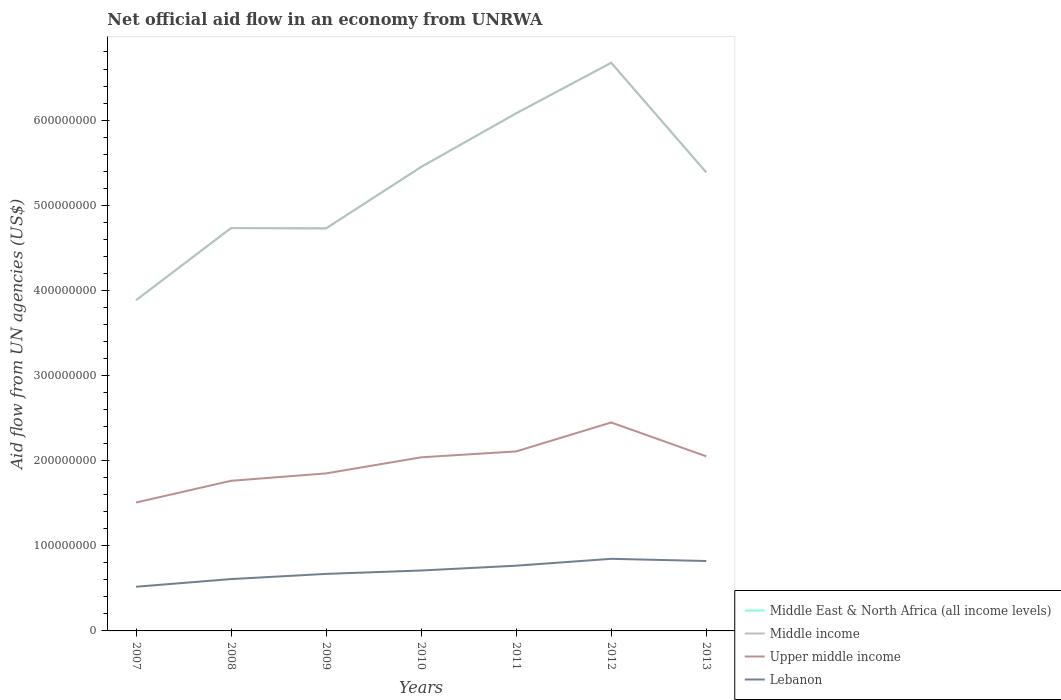Does the line corresponding to Upper middle income intersect with the line corresponding to Middle East & North Africa (all income levels)?
Offer a very short reply. No. Is the number of lines equal to the number of legend labels?
Your answer should be very brief. Yes. Across all years, what is the maximum net official aid flow in Middle East & North Africa (all income levels)?
Provide a short and direct response. 3.88e+08. What is the total net official aid flow in Upper middle income in the graph?
Offer a very short reply. -2.88e+07. What is the difference between the highest and the second highest net official aid flow in Upper middle income?
Your answer should be very brief. 9.40e+07. Is the net official aid flow in Middle income strictly greater than the net official aid flow in Upper middle income over the years?
Make the answer very short. No. How many lines are there?
Offer a terse response. 4. What is the difference between two consecutive major ticks on the Y-axis?
Give a very brief answer. 1.00e+08. Where does the legend appear in the graph?
Your answer should be very brief. Bottom right. What is the title of the graph?
Provide a succinct answer. Net official aid flow in an economy from UNRWA. Does "New Caledonia" appear as one of the legend labels in the graph?
Your answer should be very brief. No. What is the label or title of the X-axis?
Make the answer very short. Years. What is the label or title of the Y-axis?
Provide a short and direct response. Aid flow from UN agencies (US$). What is the Aid flow from UN agencies (US$) in Middle East & North Africa (all income levels) in 2007?
Give a very brief answer. 3.88e+08. What is the Aid flow from UN agencies (US$) in Middle income in 2007?
Provide a short and direct response. 3.88e+08. What is the Aid flow from UN agencies (US$) of Upper middle income in 2007?
Your answer should be very brief. 1.51e+08. What is the Aid flow from UN agencies (US$) in Lebanon in 2007?
Your answer should be compact. 5.19e+07. What is the Aid flow from UN agencies (US$) of Middle East & North Africa (all income levels) in 2008?
Give a very brief answer. 4.73e+08. What is the Aid flow from UN agencies (US$) of Middle income in 2008?
Provide a succinct answer. 4.73e+08. What is the Aid flow from UN agencies (US$) of Upper middle income in 2008?
Offer a very short reply. 1.76e+08. What is the Aid flow from UN agencies (US$) in Lebanon in 2008?
Provide a succinct answer. 6.09e+07. What is the Aid flow from UN agencies (US$) in Middle East & North Africa (all income levels) in 2009?
Your answer should be compact. 4.73e+08. What is the Aid flow from UN agencies (US$) in Middle income in 2009?
Provide a short and direct response. 4.73e+08. What is the Aid flow from UN agencies (US$) in Upper middle income in 2009?
Offer a terse response. 1.85e+08. What is the Aid flow from UN agencies (US$) in Lebanon in 2009?
Make the answer very short. 6.70e+07. What is the Aid flow from UN agencies (US$) in Middle East & North Africa (all income levels) in 2010?
Your answer should be compact. 5.45e+08. What is the Aid flow from UN agencies (US$) in Middle income in 2010?
Your answer should be very brief. 5.45e+08. What is the Aid flow from UN agencies (US$) in Upper middle income in 2010?
Offer a terse response. 2.04e+08. What is the Aid flow from UN agencies (US$) in Lebanon in 2010?
Offer a very short reply. 7.10e+07. What is the Aid flow from UN agencies (US$) of Middle East & North Africa (all income levels) in 2011?
Offer a terse response. 6.08e+08. What is the Aid flow from UN agencies (US$) in Middle income in 2011?
Your answer should be very brief. 6.08e+08. What is the Aid flow from UN agencies (US$) of Upper middle income in 2011?
Offer a terse response. 2.11e+08. What is the Aid flow from UN agencies (US$) in Lebanon in 2011?
Your answer should be compact. 7.66e+07. What is the Aid flow from UN agencies (US$) of Middle East & North Africa (all income levels) in 2012?
Offer a very short reply. 6.67e+08. What is the Aid flow from UN agencies (US$) of Middle income in 2012?
Your answer should be very brief. 6.67e+08. What is the Aid flow from UN agencies (US$) of Upper middle income in 2012?
Offer a very short reply. 2.45e+08. What is the Aid flow from UN agencies (US$) of Lebanon in 2012?
Provide a succinct answer. 8.47e+07. What is the Aid flow from UN agencies (US$) in Middle East & North Africa (all income levels) in 2013?
Make the answer very short. 5.39e+08. What is the Aid flow from UN agencies (US$) of Middle income in 2013?
Give a very brief answer. 5.39e+08. What is the Aid flow from UN agencies (US$) in Upper middle income in 2013?
Keep it short and to the point. 2.05e+08. What is the Aid flow from UN agencies (US$) of Lebanon in 2013?
Ensure brevity in your answer.  8.21e+07. Across all years, what is the maximum Aid flow from UN agencies (US$) of Middle East & North Africa (all income levels)?
Ensure brevity in your answer.  6.67e+08. Across all years, what is the maximum Aid flow from UN agencies (US$) of Middle income?
Give a very brief answer. 6.67e+08. Across all years, what is the maximum Aid flow from UN agencies (US$) of Upper middle income?
Provide a succinct answer. 2.45e+08. Across all years, what is the maximum Aid flow from UN agencies (US$) in Lebanon?
Provide a short and direct response. 8.47e+07. Across all years, what is the minimum Aid flow from UN agencies (US$) in Middle East & North Africa (all income levels)?
Your response must be concise. 3.88e+08. Across all years, what is the minimum Aid flow from UN agencies (US$) in Middle income?
Your answer should be compact. 3.88e+08. Across all years, what is the minimum Aid flow from UN agencies (US$) in Upper middle income?
Provide a succinct answer. 1.51e+08. Across all years, what is the minimum Aid flow from UN agencies (US$) in Lebanon?
Your response must be concise. 5.19e+07. What is the total Aid flow from UN agencies (US$) of Middle East & North Africa (all income levels) in the graph?
Make the answer very short. 3.69e+09. What is the total Aid flow from UN agencies (US$) in Middle income in the graph?
Provide a short and direct response. 3.69e+09. What is the total Aid flow from UN agencies (US$) of Upper middle income in the graph?
Offer a very short reply. 1.38e+09. What is the total Aid flow from UN agencies (US$) in Lebanon in the graph?
Ensure brevity in your answer.  4.94e+08. What is the difference between the Aid flow from UN agencies (US$) in Middle East & North Africa (all income levels) in 2007 and that in 2008?
Provide a short and direct response. -8.48e+07. What is the difference between the Aid flow from UN agencies (US$) of Middle income in 2007 and that in 2008?
Provide a short and direct response. -8.48e+07. What is the difference between the Aid flow from UN agencies (US$) in Upper middle income in 2007 and that in 2008?
Keep it short and to the point. -2.55e+07. What is the difference between the Aid flow from UN agencies (US$) in Lebanon in 2007 and that in 2008?
Your answer should be very brief. -9.01e+06. What is the difference between the Aid flow from UN agencies (US$) in Middle East & North Africa (all income levels) in 2007 and that in 2009?
Provide a short and direct response. -8.44e+07. What is the difference between the Aid flow from UN agencies (US$) in Middle income in 2007 and that in 2009?
Your response must be concise. -8.44e+07. What is the difference between the Aid flow from UN agencies (US$) in Upper middle income in 2007 and that in 2009?
Make the answer very short. -3.42e+07. What is the difference between the Aid flow from UN agencies (US$) in Lebanon in 2007 and that in 2009?
Give a very brief answer. -1.51e+07. What is the difference between the Aid flow from UN agencies (US$) of Middle East & North Africa (all income levels) in 2007 and that in 2010?
Keep it short and to the point. -1.57e+08. What is the difference between the Aid flow from UN agencies (US$) in Middle income in 2007 and that in 2010?
Offer a very short reply. -1.57e+08. What is the difference between the Aid flow from UN agencies (US$) in Upper middle income in 2007 and that in 2010?
Offer a terse response. -5.31e+07. What is the difference between the Aid flow from UN agencies (US$) of Lebanon in 2007 and that in 2010?
Provide a succinct answer. -1.91e+07. What is the difference between the Aid flow from UN agencies (US$) in Middle East & North Africa (all income levels) in 2007 and that in 2011?
Your answer should be compact. -2.20e+08. What is the difference between the Aid flow from UN agencies (US$) in Middle income in 2007 and that in 2011?
Provide a succinct answer. -2.20e+08. What is the difference between the Aid flow from UN agencies (US$) of Upper middle income in 2007 and that in 2011?
Provide a succinct answer. -6.00e+07. What is the difference between the Aid flow from UN agencies (US$) of Lebanon in 2007 and that in 2011?
Offer a very short reply. -2.47e+07. What is the difference between the Aid flow from UN agencies (US$) of Middle East & North Africa (all income levels) in 2007 and that in 2012?
Offer a terse response. -2.79e+08. What is the difference between the Aid flow from UN agencies (US$) of Middle income in 2007 and that in 2012?
Offer a terse response. -2.79e+08. What is the difference between the Aid flow from UN agencies (US$) of Upper middle income in 2007 and that in 2012?
Your answer should be compact. -9.40e+07. What is the difference between the Aid flow from UN agencies (US$) in Lebanon in 2007 and that in 2012?
Provide a succinct answer. -3.28e+07. What is the difference between the Aid flow from UN agencies (US$) of Middle East & North Africa (all income levels) in 2007 and that in 2013?
Give a very brief answer. -1.50e+08. What is the difference between the Aid flow from UN agencies (US$) in Middle income in 2007 and that in 2013?
Give a very brief answer. -1.50e+08. What is the difference between the Aid flow from UN agencies (US$) in Upper middle income in 2007 and that in 2013?
Provide a short and direct response. -5.43e+07. What is the difference between the Aid flow from UN agencies (US$) of Lebanon in 2007 and that in 2013?
Offer a terse response. -3.02e+07. What is the difference between the Aid flow from UN agencies (US$) of Middle income in 2008 and that in 2009?
Give a very brief answer. 3.60e+05. What is the difference between the Aid flow from UN agencies (US$) of Upper middle income in 2008 and that in 2009?
Offer a terse response. -8.69e+06. What is the difference between the Aid flow from UN agencies (US$) in Lebanon in 2008 and that in 2009?
Keep it short and to the point. -6.08e+06. What is the difference between the Aid flow from UN agencies (US$) of Middle East & North Africa (all income levels) in 2008 and that in 2010?
Your answer should be compact. -7.18e+07. What is the difference between the Aid flow from UN agencies (US$) in Middle income in 2008 and that in 2010?
Offer a terse response. -7.18e+07. What is the difference between the Aid flow from UN agencies (US$) in Upper middle income in 2008 and that in 2010?
Provide a succinct answer. -2.76e+07. What is the difference between the Aid flow from UN agencies (US$) in Lebanon in 2008 and that in 2010?
Offer a very short reply. -1.01e+07. What is the difference between the Aid flow from UN agencies (US$) in Middle East & North Africa (all income levels) in 2008 and that in 2011?
Your response must be concise. -1.35e+08. What is the difference between the Aid flow from UN agencies (US$) of Middle income in 2008 and that in 2011?
Your answer should be compact. -1.35e+08. What is the difference between the Aid flow from UN agencies (US$) of Upper middle income in 2008 and that in 2011?
Provide a short and direct response. -3.45e+07. What is the difference between the Aid flow from UN agencies (US$) in Lebanon in 2008 and that in 2011?
Your answer should be very brief. -1.57e+07. What is the difference between the Aid flow from UN agencies (US$) in Middle East & North Africa (all income levels) in 2008 and that in 2012?
Keep it short and to the point. -1.94e+08. What is the difference between the Aid flow from UN agencies (US$) of Middle income in 2008 and that in 2012?
Your response must be concise. -1.94e+08. What is the difference between the Aid flow from UN agencies (US$) of Upper middle income in 2008 and that in 2012?
Your response must be concise. -6.85e+07. What is the difference between the Aid flow from UN agencies (US$) of Lebanon in 2008 and that in 2012?
Keep it short and to the point. -2.38e+07. What is the difference between the Aid flow from UN agencies (US$) in Middle East & North Africa (all income levels) in 2008 and that in 2013?
Provide a short and direct response. -6.54e+07. What is the difference between the Aid flow from UN agencies (US$) in Middle income in 2008 and that in 2013?
Keep it short and to the point. -6.54e+07. What is the difference between the Aid flow from UN agencies (US$) of Upper middle income in 2008 and that in 2013?
Ensure brevity in your answer.  -2.88e+07. What is the difference between the Aid flow from UN agencies (US$) of Lebanon in 2008 and that in 2013?
Offer a very short reply. -2.12e+07. What is the difference between the Aid flow from UN agencies (US$) in Middle East & North Africa (all income levels) in 2009 and that in 2010?
Provide a short and direct response. -7.21e+07. What is the difference between the Aid flow from UN agencies (US$) of Middle income in 2009 and that in 2010?
Your answer should be very brief. -7.21e+07. What is the difference between the Aid flow from UN agencies (US$) of Upper middle income in 2009 and that in 2010?
Your answer should be compact. -1.89e+07. What is the difference between the Aid flow from UN agencies (US$) of Lebanon in 2009 and that in 2010?
Your answer should be compact. -3.99e+06. What is the difference between the Aid flow from UN agencies (US$) of Middle East & North Africa (all income levels) in 2009 and that in 2011?
Offer a very short reply. -1.35e+08. What is the difference between the Aid flow from UN agencies (US$) in Middle income in 2009 and that in 2011?
Make the answer very short. -1.35e+08. What is the difference between the Aid flow from UN agencies (US$) of Upper middle income in 2009 and that in 2011?
Keep it short and to the point. -2.58e+07. What is the difference between the Aid flow from UN agencies (US$) in Lebanon in 2009 and that in 2011?
Keep it short and to the point. -9.64e+06. What is the difference between the Aid flow from UN agencies (US$) of Middle East & North Africa (all income levels) in 2009 and that in 2012?
Give a very brief answer. -1.95e+08. What is the difference between the Aid flow from UN agencies (US$) in Middle income in 2009 and that in 2012?
Give a very brief answer. -1.95e+08. What is the difference between the Aid flow from UN agencies (US$) of Upper middle income in 2009 and that in 2012?
Offer a terse response. -5.98e+07. What is the difference between the Aid flow from UN agencies (US$) of Lebanon in 2009 and that in 2012?
Your response must be concise. -1.77e+07. What is the difference between the Aid flow from UN agencies (US$) of Middle East & North Africa (all income levels) in 2009 and that in 2013?
Make the answer very short. -6.58e+07. What is the difference between the Aid flow from UN agencies (US$) in Middle income in 2009 and that in 2013?
Keep it short and to the point. -6.58e+07. What is the difference between the Aid flow from UN agencies (US$) in Upper middle income in 2009 and that in 2013?
Give a very brief answer. -2.01e+07. What is the difference between the Aid flow from UN agencies (US$) in Lebanon in 2009 and that in 2013?
Keep it short and to the point. -1.51e+07. What is the difference between the Aid flow from UN agencies (US$) of Middle East & North Africa (all income levels) in 2010 and that in 2011?
Your answer should be compact. -6.30e+07. What is the difference between the Aid flow from UN agencies (US$) in Middle income in 2010 and that in 2011?
Your response must be concise. -6.30e+07. What is the difference between the Aid flow from UN agencies (US$) of Upper middle income in 2010 and that in 2011?
Provide a short and direct response. -6.94e+06. What is the difference between the Aid flow from UN agencies (US$) in Lebanon in 2010 and that in 2011?
Provide a short and direct response. -5.65e+06. What is the difference between the Aid flow from UN agencies (US$) of Middle East & North Africa (all income levels) in 2010 and that in 2012?
Give a very brief answer. -1.22e+08. What is the difference between the Aid flow from UN agencies (US$) in Middle income in 2010 and that in 2012?
Give a very brief answer. -1.22e+08. What is the difference between the Aid flow from UN agencies (US$) in Upper middle income in 2010 and that in 2012?
Provide a short and direct response. -4.09e+07. What is the difference between the Aid flow from UN agencies (US$) in Lebanon in 2010 and that in 2012?
Ensure brevity in your answer.  -1.37e+07. What is the difference between the Aid flow from UN agencies (US$) in Middle East & North Africa (all income levels) in 2010 and that in 2013?
Provide a short and direct response. 6.34e+06. What is the difference between the Aid flow from UN agencies (US$) of Middle income in 2010 and that in 2013?
Give a very brief answer. 6.34e+06. What is the difference between the Aid flow from UN agencies (US$) in Upper middle income in 2010 and that in 2013?
Offer a very short reply. -1.20e+06. What is the difference between the Aid flow from UN agencies (US$) in Lebanon in 2010 and that in 2013?
Your answer should be very brief. -1.11e+07. What is the difference between the Aid flow from UN agencies (US$) in Middle East & North Africa (all income levels) in 2011 and that in 2012?
Make the answer very short. -5.94e+07. What is the difference between the Aid flow from UN agencies (US$) in Middle income in 2011 and that in 2012?
Give a very brief answer. -5.94e+07. What is the difference between the Aid flow from UN agencies (US$) in Upper middle income in 2011 and that in 2012?
Make the answer very short. -3.40e+07. What is the difference between the Aid flow from UN agencies (US$) of Lebanon in 2011 and that in 2012?
Your response must be concise. -8.07e+06. What is the difference between the Aid flow from UN agencies (US$) in Middle East & North Africa (all income levels) in 2011 and that in 2013?
Your answer should be compact. 6.93e+07. What is the difference between the Aid flow from UN agencies (US$) of Middle income in 2011 and that in 2013?
Keep it short and to the point. 6.93e+07. What is the difference between the Aid flow from UN agencies (US$) of Upper middle income in 2011 and that in 2013?
Your response must be concise. 5.74e+06. What is the difference between the Aid flow from UN agencies (US$) in Lebanon in 2011 and that in 2013?
Keep it short and to the point. -5.49e+06. What is the difference between the Aid flow from UN agencies (US$) of Middle East & North Africa (all income levels) in 2012 and that in 2013?
Offer a terse response. 1.29e+08. What is the difference between the Aid flow from UN agencies (US$) in Middle income in 2012 and that in 2013?
Offer a very short reply. 1.29e+08. What is the difference between the Aid flow from UN agencies (US$) of Upper middle income in 2012 and that in 2013?
Offer a terse response. 3.97e+07. What is the difference between the Aid flow from UN agencies (US$) in Lebanon in 2012 and that in 2013?
Ensure brevity in your answer.  2.58e+06. What is the difference between the Aid flow from UN agencies (US$) of Middle East & North Africa (all income levels) in 2007 and the Aid flow from UN agencies (US$) of Middle income in 2008?
Your response must be concise. -8.48e+07. What is the difference between the Aid flow from UN agencies (US$) of Middle East & North Africa (all income levels) in 2007 and the Aid flow from UN agencies (US$) of Upper middle income in 2008?
Offer a terse response. 2.12e+08. What is the difference between the Aid flow from UN agencies (US$) of Middle East & North Africa (all income levels) in 2007 and the Aid flow from UN agencies (US$) of Lebanon in 2008?
Keep it short and to the point. 3.28e+08. What is the difference between the Aid flow from UN agencies (US$) of Middle income in 2007 and the Aid flow from UN agencies (US$) of Upper middle income in 2008?
Give a very brief answer. 2.12e+08. What is the difference between the Aid flow from UN agencies (US$) in Middle income in 2007 and the Aid flow from UN agencies (US$) in Lebanon in 2008?
Your answer should be compact. 3.28e+08. What is the difference between the Aid flow from UN agencies (US$) in Upper middle income in 2007 and the Aid flow from UN agencies (US$) in Lebanon in 2008?
Ensure brevity in your answer.  8.99e+07. What is the difference between the Aid flow from UN agencies (US$) in Middle East & North Africa (all income levels) in 2007 and the Aid flow from UN agencies (US$) in Middle income in 2009?
Offer a terse response. -8.44e+07. What is the difference between the Aid flow from UN agencies (US$) in Middle East & North Africa (all income levels) in 2007 and the Aid flow from UN agencies (US$) in Upper middle income in 2009?
Your answer should be very brief. 2.03e+08. What is the difference between the Aid flow from UN agencies (US$) in Middle East & North Africa (all income levels) in 2007 and the Aid flow from UN agencies (US$) in Lebanon in 2009?
Your answer should be very brief. 3.21e+08. What is the difference between the Aid flow from UN agencies (US$) in Middle income in 2007 and the Aid flow from UN agencies (US$) in Upper middle income in 2009?
Keep it short and to the point. 2.03e+08. What is the difference between the Aid flow from UN agencies (US$) of Middle income in 2007 and the Aid flow from UN agencies (US$) of Lebanon in 2009?
Offer a terse response. 3.21e+08. What is the difference between the Aid flow from UN agencies (US$) in Upper middle income in 2007 and the Aid flow from UN agencies (US$) in Lebanon in 2009?
Your answer should be compact. 8.38e+07. What is the difference between the Aid flow from UN agencies (US$) of Middle East & North Africa (all income levels) in 2007 and the Aid flow from UN agencies (US$) of Middle income in 2010?
Ensure brevity in your answer.  -1.57e+08. What is the difference between the Aid flow from UN agencies (US$) in Middle East & North Africa (all income levels) in 2007 and the Aid flow from UN agencies (US$) in Upper middle income in 2010?
Offer a terse response. 1.85e+08. What is the difference between the Aid flow from UN agencies (US$) of Middle East & North Africa (all income levels) in 2007 and the Aid flow from UN agencies (US$) of Lebanon in 2010?
Provide a short and direct response. 3.17e+08. What is the difference between the Aid flow from UN agencies (US$) of Middle income in 2007 and the Aid flow from UN agencies (US$) of Upper middle income in 2010?
Your response must be concise. 1.85e+08. What is the difference between the Aid flow from UN agencies (US$) in Middle income in 2007 and the Aid flow from UN agencies (US$) in Lebanon in 2010?
Offer a terse response. 3.17e+08. What is the difference between the Aid flow from UN agencies (US$) in Upper middle income in 2007 and the Aid flow from UN agencies (US$) in Lebanon in 2010?
Ensure brevity in your answer.  7.98e+07. What is the difference between the Aid flow from UN agencies (US$) in Middle East & North Africa (all income levels) in 2007 and the Aid flow from UN agencies (US$) in Middle income in 2011?
Keep it short and to the point. -2.20e+08. What is the difference between the Aid flow from UN agencies (US$) of Middle East & North Africa (all income levels) in 2007 and the Aid flow from UN agencies (US$) of Upper middle income in 2011?
Your answer should be very brief. 1.78e+08. What is the difference between the Aid flow from UN agencies (US$) in Middle East & North Africa (all income levels) in 2007 and the Aid flow from UN agencies (US$) in Lebanon in 2011?
Offer a terse response. 3.12e+08. What is the difference between the Aid flow from UN agencies (US$) of Middle income in 2007 and the Aid flow from UN agencies (US$) of Upper middle income in 2011?
Provide a short and direct response. 1.78e+08. What is the difference between the Aid flow from UN agencies (US$) in Middle income in 2007 and the Aid flow from UN agencies (US$) in Lebanon in 2011?
Offer a very short reply. 3.12e+08. What is the difference between the Aid flow from UN agencies (US$) in Upper middle income in 2007 and the Aid flow from UN agencies (US$) in Lebanon in 2011?
Make the answer very short. 7.42e+07. What is the difference between the Aid flow from UN agencies (US$) in Middle East & North Africa (all income levels) in 2007 and the Aid flow from UN agencies (US$) in Middle income in 2012?
Ensure brevity in your answer.  -2.79e+08. What is the difference between the Aid flow from UN agencies (US$) of Middle East & North Africa (all income levels) in 2007 and the Aid flow from UN agencies (US$) of Upper middle income in 2012?
Offer a terse response. 1.44e+08. What is the difference between the Aid flow from UN agencies (US$) of Middle East & North Africa (all income levels) in 2007 and the Aid flow from UN agencies (US$) of Lebanon in 2012?
Offer a very short reply. 3.04e+08. What is the difference between the Aid flow from UN agencies (US$) in Middle income in 2007 and the Aid flow from UN agencies (US$) in Upper middle income in 2012?
Ensure brevity in your answer.  1.44e+08. What is the difference between the Aid flow from UN agencies (US$) of Middle income in 2007 and the Aid flow from UN agencies (US$) of Lebanon in 2012?
Provide a succinct answer. 3.04e+08. What is the difference between the Aid flow from UN agencies (US$) in Upper middle income in 2007 and the Aid flow from UN agencies (US$) in Lebanon in 2012?
Offer a very short reply. 6.61e+07. What is the difference between the Aid flow from UN agencies (US$) in Middle East & North Africa (all income levels) in 2007 and the Aid flow from UN agencies (US$) in Middle income in 2013?
Your answer should be very brief. -1.50e+08. What is the difference between the Aid flow from UN agencies (US$) of Middle East & North Africa (all income levels) in 2007 and the Aid flow from UN agencies (US$) of Upper middle income in 2013?
Your answer should be compact. 1.83e+08. What is the difference between the Aid flow from UN agencies (US$) in Middle East & North Africa (all income levels) in 2007 and the Aid flow from UN agencies (US$) in Lebanon in 2013?
Offer a terse response. 3.06e+08. What is the difference between the Aid flow from UN agencies (US$) of Middle income in 2007 and the Aid flow from UN agencies (US$) of Upper middle income in 2013?
Ensure brevity in your answer.  1.83e+08. What is the difference between the Aid flow from UN agencies (US$) of Middle income in 2007 and the Aid flow from UN agencies (US$) of Lebanon in 2013?
Provide a short and direct response. 3.06e+08. What is the difference between the Aid flow from UN agencies (US$) in Upper middle income in 2007 and the Aid flow from UN agencies (US$) in Lebanon in 2013?
Provide a succinct answer. 6.87e+07. What is the difference between the Aid flow from UN agencies (US$) in Middle East & North Africa (all income levels) in 2008 and the Aid flow from UN agencies (US$) in Upper middle income in 2009?
Your response must be concise. 2.88e+08. What is the difference between the Aid flow from UN agencies (US$) of Middle East & North Africa (all income levels) in 2008 and the Aid flow from UN agencies (US$) of Lebanon in 2009?
Keep it short and to the point. 4.06e+08. What is the difference between the Aid flow from UN agencies (US$) in Middle income in 2008 and the Aid flow from UN agencies (US$) in Upper middle income in 2009?
Your answer should be compact. 2.88e+08. What is the difference between the Aid flow from UN agencies (US$) of Middle income in 2008 and the Aid flow from UN agencies (US$) of Lebanon in 2009?
Give a very brief answer. 4.06e+08. What is the difference between the Aid flow from UN agencies (US$) of Upper middle income in 2008 and the Aid flow from UN agencies (US$) of Lebanon in 2009?
Your answer should be very brief. 1.09e+08. What is the difference between the Aid flow from UN agencies (US$) in Middle East & North Africa (all income levels) in 2008 and the Aid flow from UN agencies (US$) in Middle income in 2010?
Provide a short and direct response. -7.18e+07. What is the difference between the Aid flow from UN agencies (US$) in Middle East & North Africa (all income levels) in 2008 and the Aid flow from UN agencies (US$) in Upper middle income in 2010?
Offer a very short reply. 2.69e+08. What is the difference between the Aid flow from UN agencies (US$) in Middle East & North Africa (all income levels) in 2008 and the Aid flow from UN agencies (US$) in Lebanon in 2010?
Your response must be concise. 4.02e+08. What is the difference between the Aid flow from UN agencies (US$) of Middle income in 2008 and the Aid flow from UN agencies (US$) of Upper middle income in 2010?
Your answer should be very brief. 2.69e+08. What is the difference between the Aid flow from UN agencies (US$) in Middle income in 2008 and the Aid flow from UN agencies (US$) in Lebanon in 2010?
Offer a very short reply. 4.02e+08. What is the difference between the Aid flow from UN agencies (US$) of Upper middle income in 2008 and the Aid flow from UN agencies (US$) of Lebanon in 2010?
Give a very brief answer. 1.05e+08. What is the difference between the Aid flow from UN agencies (US$) of Middle East & North Africa (all income levels) in 2008 and the Aid flow from UN agencies (US$) of Middle income in 2011?
Keep it short and to the point. -1.35e+08. What is the difference between the Aid flow from UN agencies (US$) in Middle East & North Africa (all income levels) in 2008 and the Aid flow from UN agencies (US$) in Upper middle income in 2011?
Ensure brevity in your answer.  2.62e+08. What is the difference between the Aid flow from UN agencies (US$) in Middle East & North Africa (all income levels) in 2008 and the Aid flow from UN agencies (US$) in Lebanon in 2011?
Keep it short and to the point. 3.97e+08. What is the difference between the Aid flow from UN agencies (US$) of Middle income in 2008 and the Aid flow from UN agencies (US$) of Upper middle income in 2011?
Provide a succinct answer. 2.62e+08. What is the difference between the Aid flow from UN agencies (US$) in Middle income in 2008 and the Aid flow from UN agencies (US$) in Lebanon in 2011?
Provide a short and direct response. 3.97e+08. What is the difference between the Aid flow from UN agencies (US$) in Upper middle income in 2008 and the Aid flow from UN agencies (US$) in Lebanon in 2011?
Your answer should be very brief. 9.97e+07. What is the difference between the Aid flow from UN agencies (US$) in Middle East & North Africa (all income levels) in 2008 and the Aid flow from UN agencies (US$) in Middle income in 2012?
Offer a terse response. -1.94e+08. What is the difference between the Aid flow from UN agencies (US$) of Middle East & North Africa (all income levels) in 2008 and the Aid flow from UN agencies (US$) of Upper middle income in 2012?
Give a very brief answer. 2.28e+08. What is the difference between the Aid flow from UN agencies (US$) of Middle East & North Africa (all income levels) in 2008 and the Aid flow from UN agencies (US$) of Lebanon in 2012?
Your response must be concise. 3.88e+08. What is the difference between the Aid flow from UN agencies (US$) in Middle income in 2008 and the Aid flow from UN agencies (US$) in Upper middle income in 2012?
Give a very brief answer. 2.28e+08. What is the difference between the Aid flow from UN agencies (US$) of Middle income in 2008 and the Aid flow from UN agencies (US$) of Lebanon in 2012?
Your answer should be very brief. 3.88e+08. What is the difference between the Aid flow from UN agencies (US$) in Upper middle income in 2008 and the Aid flow from UN agencies (US$) in Lebanon in 2012?
Your response must be concise. 9.16e+07. What is the difference between the Aid flow from UN agencies (US$) of Middle East & North Africa (all income levels) in 2008 and the Aid flow from UN agencies (US$) of Middle income in 2013?
Make the answer very short. -6.54e+07. What is the difference between the Aid flow from UN agencies (US$) of Middle East & North Africa (all income levels) in 2008 and the Aid flow from UN agencies (US$) of Upper middle income in 2013?
Give a very brief answer. 2.68e+08. What is the difference between the Aid flow from UN agencies (US$) in Middle East & North Africa (all income levels) in 2008 and the Aid flow from UN agencies (US$) in Lebanon in 2013?
Offer a very short reply. 3.91e+08. What is the difference between the Aid flow from UN agencies (US$) in Middle income in 2008 and the Aid flow from UN agencies (US$) in Upper middle income in 2013?
Your answer should be very brief. 2.68e+08. What is the difference between the Aid flow from UN agencies (US$) in Middle income in 2008 and the Aid flow from UN agencies (US$) in Lebanon in 2013?
Give a very brief answer. 3.91e+08. What is the difference between the Aid flow from UN agencies (US$) in Upper middle income in 2008 and the Aid flow from UN agencies (US$) in Lebanon in 2013?
Offer a terse response. 9.42e+07. What is the difference between the Aid flow from UN agencies (US$) in Middle East & North Africa (all income levels) in 2009 and the Aid flow from UN agencies (US$) in Middle income in 2010?
Ensure brevity in your answer.  -7.21e+07. What is the difference between the Aid flow from UN agencies (US$) in Middle East & North Africa (all income levels) in 2009 and the Aid flow from UN agencies (US$) in Upper middle income in 2010?
Ensure brevity in your answer.  2.69e+08. What is the difference between the Aid flow from UN agencies (US$) of Middle East & North Africa (all income levels) in 2009 and the Aid flow from UN agencies (US$) of Lebanon in 2010?
Provide a short and direct response. 4.02e+08. What is the difference between the Aid flow from UN agencies (US$) in Middle income in 2009 and the Aid flow from UN agencies (US$) in Upper middle income in 2010?
Offer a very short reply. 2.69e+08. What is the difference between the Aid flow from UN agencies (US$) of Middle income in 2009 and the Aid flow from UN agencies (US$) of Lebanon in 2010?
Provide a short and direct response. 4.02e+08. What is the difference between the Aid flow from UN agencies (US$) in Upper middle income in 2009 and the Aid flow from UN agencies (US$) in Lebanon in 2010?
Your answer should be compact. 1.14e+08. What is the difference between the Aid flow from UN agencies (US$) in Middle East & North Africa (all income levels) in 2009 and the Aid flow from UN agencies (US$) in Middle income in 2011?
Give a very brief answer. -1.35e+08. What is the difference between the Aid flow from UN agencies (US$) in Middle East & North Africa (all income levels) in 2009 and the Aid flow from UN agencies (US$) in Upper middle income in 2011?
Offer a terse response. 2.62e+08. What is the difference between the Aid flow from UN agencies (US$) in Middle East & North Africa (all income levels) in 2009 and the Aid flow from UN agencies (US$) in Lebanon in 2011?
Give a very brief answer. 3.96e+08. What is the difference between the Aid flow from UN agencies (US$) of Middle income in 2009 and the Aid flow from UN agencies (US$) of Upper middle income in 2011?
Your answer should be compact. 2.62e+08. What is the difference between the Aid flow from UN agencies (US$) of Middle income in 2009 and the Aid flow from UN agencies (US$) of Lebanon in 2011?
Your answer should be very brief. 3.96e+08. What is the difference between the Aid flow from UN agencies (US$) in Upper middle income in 2009 and the Aid flow from UN agencies (US$) in Lebanon in 2011?
Offer a very short reply. 1.08e+08. What is the difference between the Aid flow from UN agencies (US$) of Middle East & North Africa (all income levels) in 2009 and the Aid flow from UN agencies (US$) of Middle income in 2012?
Your answer should be compact. -1.95e+08. What is the difference between the Aid flow from UN agencies (US$) of Middle East & North Africa (all income levels) in 2009 and the Aid flow from UN agencies (US$) of Upper middle income in 2012?
Your response must be concise. 2.28e+08. What is the difference between the Aid flow from UN agencies (US$) of Middle East & North Africa (all income levels) in 2009 and the Aid flow from UN agencies (US$) of Lebanon in 2012?
Your answer should be compact. 3.88e+08. What is the difference between the Aid flow from UN agencies (US$) of Middle income in 2009 and the Aid flow from UN agencies (US$) of Upper middle income in 2012?
Give a very brief answer. 2.28e+08. What is the difference between the Aid flow from UN agencies (US$) of Middle income in 2009 and the Aid flow from UN agencies (US$) of Lebanon in 2012?
Offer a very short reply. 3.88e+08. What is the difference between the Aid flow from UN agencies (US$) in Upper middle income in 2009 and the Aid flow from UN agencies (US$) in Lebanon in 2012?
Offer a terse response. 1.00e+08. What is the difference between the Aid flow from UN agencies (US$) in Middle East & North Africa (all income levels) in 2009 and the Aid flow from UN agencies (US$) in Middle income in 2013?
Provide a succinct answer. -6.58e+07. What is the difference between the Aid flow from UN agencies (US$) in Middle East & North Africa (all income levels) in 2009 and the Aid flow from UN agencies (US$) in Upper middle income in 2013?
Offer a terse response. 2.68e+08. What is the difference between the Aid flow from UN agencies (US$) in Middle East & North Africa (all income levels) in 2009 and the Aid flow from UN agencies (US$) in Lebanon in 2013?
Offer a terse response. 3.91e+08. What is the difference between the Aid flow from UN agencies (US$) of Middle income in 2009 and the Aid flow from UN agencies (US$) of Upper middle income in 2013?
Keep it short and to the point. 2.68e+08. What is the difference between the Aid flow from UN agencies (US$) in Middle income in 2009 and the Aid flow from UN agencies (US$) in Lebanon in 2013?
Provide a short and direct response. 3.91e+08. What is the difference between the Aid flow from UN agencies (US$) in Upper middle income in 2009 and the Aid flow from UN agencies (US$) in Lebanon in 2013?
Keep it short and to the point. 1.03e+08. What is the difference between the Aid flow from UN agencies (US$) in Middle East & North Africa (all income levels) in 2010 and the Aid flow from UN agencies (US$) in Middle income in 2011?
Your answer should be compact. -6.30e+07. What is the difference between the Aid flow from UN agencies (US$) in Middle East & North Africa (all income levels) in 2010 and the Aid flow from UN agencies (US$) in Upper middle income in 2011?
Your response must be concise. 3.34e+08. What is the difference between the Aid flow from UN agencies (US$) in Middle East & North Africa (all income levels) in 2010 and the Aid flow from UN agencies (US$) in Lebanon in 2011?
Your answer should be compact. 4.68e+08. What is the difference between the Aid flow from UN agencies (US$) in Middle income in 2010 and the Aid flow from UN agencies (US$) in Upper middle income in 2011?
Provide a short and direct response. 3.34e+08. What is the difference between the Aid flow from UN agencies (US$) of Middle income in 2010 and the Aid flow from UN agencies (US$) of Lebanon in 2011?
Offer a very short reply. 4.68e+08. What is the difference between the Aid flow from UN agencies (US$) of Upper middle income in 2010 and the Aid flow from UN agencies (US$) of Lebanon in 2011?
Your answer should be compact. 1.27e+08. What is the difference between the Aid flow from UN agencies (US$) in Middle East & North Africa (all income levels) in 2010 and the Aid flow from UN agencies (US$) in Middle income in 2012?
Your response must be concise. -1.22e+08. What is the difference between the Aid flow from UN agencies (US$) of Middle East & North Africa (all income levels) in 2010 and the Aid flow from UN agencies (US$) of Upper middle income in 2012?
Give a very brief answer. 3.00e+08. What is the difference between the Aid flow from UN agencies (US$) in Middle East & North Africa (all income levels) in 2010 and the Aid flow from UN agencies (US$) in Lebanon in 2012?
Your answer should be very brief. 4.60e+08. What is the difference between the Aid flow from UN agencies (US$) of Middle income in 2010 and the Aid flow from UN agencies (US$) of Upper middle income in 2012?
Give a very brief answer. 3.00e+08. What is the difference between the Aid flow from UN agencies (US$) of Middle income in 2010 and the Aid flow from UN agencies (US$) of Lebanon in 2012?
Keep it short and to the point. 4.60e+08. What is the difference between the Aid flow from UN agencies (US$) of Upper middle income in 2010 and the Aid flow from UN agencies (US$) of Lebanon in 2012?
Your response must be concise. 1.19e+08. What is the difference between the Aid flow from UN agencies (US$) of Middle East & North Africa (all income levels) in 2010 and the Aid flow from UN agencies (US$) of Middle income in 2013?
Provide a succinct answer. 6.34e+06. What is the difference between the Aid flow from UN agencies (US$) of Middle East & North Africa (all income levels) in 2010 and the Aid flow from UN agencies (US$) of Upper middle income in 2013?
Offer a very short reply. 3.40e+08. What is the difference between the Aid flow from UN agencies (US$) in Middle East & North Africa (all income levels) in 2010 and the Aid flow from UN agencies (US$) in Lebanon in 2013?
Provide a succinct answer. 4.63e+08. What is the difference between the Aid flow from UN agencies (US$) of Middle income in 2010 and the Aid flow from UN agencies (US$) of Upper middle income in 2013?
Your answer should be very brief. 3.40e+08. What is the difference between the Aid flow from UN agencies (US$) of Middle income in 2010 and the Aid flow from UN agencies (US$) of Lebanon in 2013?
Provide a short and direct response. 4.63e+08. What is the difference between the Aid flow from UN agencies (US$) of Upper middle income in 2010 and the Aid flow from UN agencies (US$) of Lebanon in 2013?
Make the answer very short. 1.22e+08. What is the difference between the Aid flow from UN agencies (US$) in Middle East & North Africa (all income levels) in 2011 and the Aid flow from UN agencies (US$) in Middle income in 2012?
Make the answer very short. -5.94e+07. What is the difference between the Aid flow from UN agencies (US$) in Middle East & North Africa (all income levels) in 2011 and the Aid flow from UN agencies (US$) in Upper middle income in 2012?
Offer a terse response. 3.63e+08. What is the difference between the Aid flow from UN agencies (US$) of Middle East & North Africa (all income levels) in 2011 and the Aid flow from UN agencies (US$) of Lebanon in 2012?
Keep it short and to the point. 5.23e+08. What is the difference between the Aid flow from UN agencies (US$) in Middle income in 2011 and the Aid flow from UN agencies (US$) in Upper middle income in 2012?
Ensure brevity in your answer.  3.63e+08. What is the difference between the Aid flow from UN agencies (US$) in Middle income in 2011 and the Aid flow from UN agencies (US$) in Lebanon in 2012?
Give a very brief answer. 5.23e+08. What is the difference between the Aid flow from UN agencies (US$) of Upper middle income in 2011 and the Aid flow from UN agencies (US$) of Lebanon in 2012?
Give a very brief answer. 1.26e+08. What is the difference between the Aid flow from UN agencies (US$) of Middle East & North Africa (all income levels) in 2011 and the Aid flow from UN agencies (US$) of Middle income in 2013?
Your response must be concise. 6.93e+07. What is the difference between the Aid flow from UN agencies (US$) of Middle East & North Africa (all income levels) in 2011 and the Aid flow from UN agencies (US$) of Upper middle income in 2013?
Your response must be concise. 4.03e+08. What is the difference between the Aid flow from UN agencies (US$) in Middle East & North Africa (all income levels) in 2011 and the Aid flow from UN agencies (US$) in Lebanon in 2013?
Make the answer very short. 5.26e+08. What is the difference between the Aid flow from UN agencies (US$) in Middle income in 2011 and the Aid flow from UN agencies (US$) in Upper middle income in 2013?
Your answer should be very brief. 4.03e+08. What is the difference between the Aid flow from UN agencies (US$) in Middle income in 2011 and the Aid flow from UN agencies (US$) in Lebanon in 2013?
Ensure brevity in your answer.  5.26e+08. What is the difference between the Aid flow from UN agencies (US$) in Upper middle income in 2011 and the Aid flow from UN agencies (US$) in Lebanon in 2013?
Provide a short and direct response. 1.29e+08. What is the difference between the Aid flow from UN agencies (US$) of Middle East & North Africa (all income levels) in 2012 and the Aid flow from UN agencies (US$) of Middle income in 2013?
Offer a terse response. 1.29e+08. What is the difference between the Aid flow from UN agencies (US$) of Middle East & North Africa (all income levels) in 2012 and the Aid flow from UN agencies (US$) of Upper middle income in 2013?
Provide a succinct answer. 4.62e+08. What is the difference between the Aid flow from UN agencies (US$) in Middle East & North Africa (all income levels) in 2012 and the Aid flow from UN agencies (US$) in Lebanon in 2013?
Make the answer very short. 5.85e+08. What is the difference between the Aid flow from UN agencies (US$) of Middle income in 2012 and the Aid flow from UN agencies (US$) of Upper middle income in 2013?
Ensure brevity in your answer.  4.62e+08. What is the difference between the Aid flow from UN agencies (US$) of Middle income in 2012 and the Aid flow from UN agencies (US$) of Lebanon in 2013?
Provide a short and direct response. 5.85e+08. What is the difference between the Aid flow from UN agencies (US$) in Upper middle income in 2012 and the Aid flow from UN agencies (US$) in Lebanon in 2013?
Provide a succinct answer. 1.63e+08. What is the average Aid flow from UN agencies (US$) in Middle East & North Africa (all income levels) per year?
Your response must be concise. 5.28e+08. What is the average Aid flow from UN agencies (US$) in Middle income per year?
Offer a terse response. 5.28e+08. What is the average Aid flow from UN agencies (US$) in Upper middle income per year?
Your answer should be compact. 1.97e+08. What is the average Aid flow from UN agencies (US$) in Lebanon per year?
Provide a short and direct response. 7.06e+07. In the year 2007, what is the difference between the Aid flow from UN agencies (US$) in Middle East & North Africa (all income levels) and Aid flow from UN agencies (US$) in Middle income?
Provide a short and direct response. 0. In the year 2007, what is the difference between the Aid flow from UN agencies (US$) of Middle East & North Africa (all income levels) and Aid flow from UN agencies (US$) of Upper middle income?
Keep it short and to the point. 2.38e+08. In the year 2007, what is the difference between the Aid flow from UN agencies (US$) in Middle East & North Africa (all income levels) and Aid flow from UN agencies (US$) in Lebanon?
Offer a very short reply. 3.37e+08. In the year 2007, what is the difference between the Aid flow from UN agencies (US$) of Middle income and Aid flow from UN agencies (US$) of Upper middle income?
Your answer should be compact. 2.38e+08. In the year 2007, what is the difference between the Aid flow from UN agencies (US$) of Middle income and Aid flow from UN agencies (US$) of Lebanon?
Ensure brevity in your answer.  3.37e+08. In the year 2007, what is the difference between the Aid flow from UN agencies (US$) in Upper middle income and Aid flow from UN agencies (US$) in Lebanon?
Provide a succinct answer. 9.89e+07. In the year 2008, what is the difference between the Aid flow from UN agencies (US$) of Middle East & North Africa (all income levels) and Aid flow from UN agencies (US$) of Middle income?
Make the answer very short. 0. In the year 2008, what is the difference between the Aid flow from UN agencies (US$) of Middle East & North Africa (all income levels) and Aid flow from UN agencies (US$) of Upper middle income?
Offer a very short reply. 2.97e+08. In the year 2008, what is the difference between the Aid flow from UN agencies (US$) of Middle East & North Africa (all income levels) and Aid flow from UN agencies (US$) of Lebanon?
Provide a short and direct response. 4.12e+08. In the year 2008, what is the difference between the Aid flow from UN agencies (US$) in Middle income and Aid flow from UN agencies (US$) in Upper middle income?
Your answer should be very brief. 2.97e+08. In the year 2008, what is the difference between the Aid flow from UN agencies (US$) in Middle income and Aid flow from UN agencies (US$) in Lebanon?
Keep it short and to the point. 4.12e+08. In the year 2008, what is the difference between the Aid flow from UN agencies (US$) in Upper middle income and Aid flow from UN agencies (US$) in Lebanon?
Your answer should be very brief. 1.15e+08. In the year 2009, what is the difference between the Aid flow from UN agencies (US$) in Middle East & North Africa (all income levels) and Aid flow from UN agencies (US$) in Middle income?
Keep it short and to the point. 0. In the year 2009, what is the difference between the Aid flow from UN agencies (US$) in Middle East & North Africa (all income levels) and Aid flow from UN agencies (US$) in Upper middle income?
Make the answer very short. 2.88e+08. In the year 2009, what is the difference between the Aid flow from UN agencies (US$) in Middle East & North Africa (all income levels) and Aid flow from UN agencies (US$) in Lebanon?
Provide a short and direct response. 4.06e+08. In the year 2009, what is the difference between the Aid flow from UN agencies (US$) of Middle income and Aid flow from UN agencies (US$) of Upper middle income?
Offer a terse response. 2.88e+08. In the year 2009, what is the difference between the Aid flow from UN agencies (US$) of Middle income and Aid flow from UN agencies (US$) of Lebanon?
Provide a succinct answer. 4.06e+08. In the year 2009, what is the difference between the Aid flow from UN agencies (US$) of Upper middle income and Aid flow from UN agencies (US$) of Lebanon?
Give a very brief answer. 1.18e+08. In the year 2010, what is the difference between the Aid flow from UN agencies (US$) in Middle East & North Africa (all income levels) and Aid flow from UN agencies (US$) in Upper middle income?
Your answer should be compact. 3.41e+08. In the year 2010, what is the difference between the Aid flow from UN agencies (US$) in Middle East & North Africa (all income levels) and Aid flow from UN agencies (US$) in Lebanon?
Your response must be concise. 4.74e+08. In the year 2010, what is the difference between the Aid flow from UN agencies (US$) of Middle income and Aid flow from UN agencies (US$) of Upper middle income?
Your response must be concise. 3.41e+08. In the year 2010, what is the difference between the Aid flow from UN agencies (US$) in Middle income and Aid flow from UN agencies (US$) in Lebanon?
Provide a succinct answer. 4.74e+08. In the year 2010, what is the difference between the Aid flow from UN agencies (US$) in Upper middle income and Aid flow from UN agencies (US$) in Lebanon?
Your response must be concise. 1.33e+08. In the year 2011, what is the difference between the Aid flow from UN agencies (US$) of Middle East & North Africa (all income levels) and Aid flow from UN agencies (US$) of Middle income?
Give a very brief answer. 0. In the year 2011, what is the difference between the Aid flow from UN agencies (US$) in Middle East & North Africa (all income levels) and Aid flow from UN agencies (US$) in Upper middle income?
Give a very brief answer. 3.97e+08. In the year 2011, what is the difference between the Aid flow from UN agencies (US$) of Middle East & North Africa (all income levels) and Aid flow from UN agencies (US$) of Lebanon?
Your response must be concise. 5.31e+08. In the year 2011, what is the difference between the Aid flow from UN agencies (US$) of Middle income and Aid flow from UN agencies (US$) of Upper middle income?
Your answer should be very brief. 3.97e+08. In the year 2011, what is the difference between the Aid flow from UN agencies (US$) of Middle income and Aid flow from UN agencies (US$) of Lebanon?
Keep it short and to the point. 5.31e+08. In the year 2011, what is the difference between the Aid flow from UN agencies (US$) in Upper middle income and Aid flow from UN agencies (US$) in Lebanon?
Your response must be concise. 1.34e+08. In the year 2012, what is the difference between the Aid flow from UN agencies (US$) of Middle East & North Africa (all income levels) and Aid flow from UN agencies (US$) of Upper middle income?
Your answer should be compact. 4.22e+08. In the year 2012, what is the difference between the Aid flow from UN agencies (US$) of Middle East & North Africa (all income levels) and Aid flow from UN agencies (US$) of Lebanon?
Provide a succinct answer. 5.83e+08. In the year 2012, what is the difference between the Aid flow from UN agencies (US$) of Middle income and Aid flow from UN agencies (US$) of Upper middle income?
Your answer should be compact. 4.22e+08. In the year 2012, what is the difference between the Aid flow from UN agencies (US$) in Middle income and Aid flow from UN agencies (US$) in Lebanon?
Your response must be concise. 5.83e+08. In the year 2012, what is the difference between the Aid flow from UN agencies (US$) in Upper middle income and Aid flow from UN agencies (US$) in Lebanon?
Provide a short and direct response. 1.60e+08. In the year 2013, what is the difference between the Aid flow from UN agencies (US$) of Middle East & North Africa (all income levels) and Aid flow from UN agencies (US$) of Upper middle income?
Your answer should be very brief. 3.34e+08. In the year 2013, what is the difference between the Aid flow from UN agencies (US$) in Middle East & North Africa (all income levels) and Aid flow from UN agencies (US$) in Lebanon?
Keep it short and to the point. 4.57e+08. In the year 2013, what is the difference between the Aid flow from UN agencies (US$) in Middle income and Aid flow from UN agencies (US$) in Upper middle income?
Your answer should be compact. 3.34e+08. In the year 2013, what is the difference between the Aid flow from UN agencies (US$) in Middle income and Aid flow from UN agencies (US$) in Lebanon?
Give a very brief answer. 4.57e+08. In the year 2013, what is the difference between the Aid flow from UN agencies (US$) of Upper middle income and Aid flow from UN agencies (US$) of Lebanon?
Offer a very short reply. 1.23e+08. What is the ratio of the Aid flow from UN agencies (US$) in Middle East & North Africa (all income levels) in 2007 to that in 2008?
Your answer should be very brief. 0.82. What is the ratio of the Aid flow from UN agencies (US$) in Middle income in 2007 to that in 2008?
Your answer should be compact. 0.82. What is the ratio of the Aid flow from UN agencies (US$) in Upper middle income in 2007 to that in 2008?
Your response must be concise. 0.86. What is the ratio of the Aid flow from UN agencies (US$) of Lebanon in 2007 to that in 2008?
Keep it short and to the point. 0.85. What is the ratio of the Aid flow from UN agencies (US$) in Middle East & North Africa (all income levels) in 2007 to that in 2009?
Make the answer very short. 0.82. What is the ratio of the Aid flow from UN agencies (US$) of Middle income in 2007 to that in 2009?
Offer a terse response. 0.82. What is the ratio of the Aid flow from UN agencies (US$) of Upper middle income in 2007 to that in 2009?
Give a very brief answer. 0.82. What is the ratio of the Aid flow from UN agencies (US$) in Lebanon in 2007 to that in 2009?
Your answer should be very brief. 0.77. What is the ratio of the Aid flow from UN agencies (US$) of Middle East & North Africa (all income levels) in 2007 to that in 2010?
Offer a terse response. 0.71. What is the ratio of the Aid flow from UN agencies (US$) in Middle income in 2007 to that in 2010?
Keep it short and to the point. 0.71. What is the ratio of the Aid flow from UN agencies (US$) in Upper middle income in 2007 to that in 2010?
Make the answer very short. 0.74. What is the ratio of the Aid flow from UN agencies (US$) of Lebanon in 2007 to that in 2010?
Make the answer very short. 0.73. What is the ratio of the Aid flow from UN agencies (US$) of Middle East & North Africa (all income levels) in 2007 to that in 2011?
Give a very brief answer. 0.64. What is the ratio of the Aid flow from UN agencies (US$) in Middle income in 2007 to that in 2011?
Make the answer very short. 0.64. What is the ratio of the Aid flow from UN agencies (US$) in Upper middle income in 2007 to that in 2011?
Your answer should be compact. 0.72. What is the ratio of the Aid flow from UN agencies (US$) of Lebanon in 2007 to that in 2011?
Provide a short and direct response. 0.68. What is the ratio of the Aid flow from UN agencies (US$) of Middle East & North Africa (all income levels) in 2007 to that in 2012?
Give a very brief answer. 0.58. What is the ratio of the Aid flow from UN agencies (US$) in Middle income in 2007 to that in 2012?
Ensure brevity in your answer.  0.58. What is the ratio of the Aid flow from UN agencies (US$) in Upper middle income in 2007 to that in 2012?
Your response must be concise. 0.62. What is the ratio of the Aid flow from UN agencies (US$) of Lebanon in 2007 to that in 2012?
Offer a terse response. 0.61. What is the ratio of the Aid flow from UN agencies (US$) in Middle East & North Africa (all income levels) in 2007 to that in 2013?
Make the answer very short. 0.72. What is the ratio of the Aid flow from UN agencies (US$) of Middle income in 2007 to that in 2013?
Make the answer very short. 0.72. What is the ratio of the Aid flow from UN agencies (US$) in Upper middle income in 2007 to that in 2013?
Make the answer very short. 0.74. What is the ratio of the Aid flow from UN agencies (US$) of Lebanon in 2007 to that in 2013?
Provide a succinct answer. 0.63. What is the ratio of the Aid flow from UN agencies (US$) in Middle income in 2008 to that in 2009?
Provide a succinct answer. 1. What is the ratio of the Aid flow from UN agencies (US$) of Upper middle income in 2008 to that in 2009?
Ensure brevity in your answer.  0.95. What is the ratio of the Aid flow from UN agencies (US$) in Lebanon in 2008 to that in 2009?
Ensure brevity in your answer.  0.91. What is the ratio of the Aid flow from UN agencies (US$) of Middle East & North Africa (all income levels) in 2008 to that in 2010?
Offer a very short reply. 0.87. What is the ratio of the Aid flow from UN agencies (US$) in Middle income in 2008 to that in 2010?
Provide a short and direct response. 0.87. What is the ratio of the Aid flow from UN agencies (US$) in Upper middle income in 2008 to that in 2010?
Your response must be concise. 0.86. What is the ratio of the Aid flow from UN agencies (US$) of Lebanon in 2008 to that in 2010?
Provide a succinct answer. 0.86. What is the ratio of the Aid flow from UN agencies (US$) in Middle East & North Africa (all income levels) in 2008 to that in 2011?
Give a very brief answer. 0.78. What is the ratio of the Aid flow from UN agencies (US$) of Middle income in 2008 to that in 2011?
Give a very brief answer. 0.78. What is the ratio of the Aid flow from UN agencies (US$) of Upper middle income in 2008 to that in 2011?
Provide a short and direct response. 0.84. What is the ratio of the Aid flow from UN agencies (US$) in Lebanon in 2008 to that in 2011?
Make the answer very short. 0.79. What is the ratio of the Aid flow from UN agencies (US$) in Middle East & North Africa (all income levels) in 2008 to that in 2012?
Keep it short and to the point. 0.71. What is the ratio of the Aid flow from UN agencies (US$) in Middle income in 2008 to that in 2012?
Offer a terse response. 0.71. What is the ratio of the Aid flow from UN agencies (US$) of Upper middle income in 2008 to that in 2012?
Keep it short and to the point. 0.72. What is the ratio of the Aid flow from UN agencies (US$) of Lebanon in 2008 to that in 2012?
Your response must be concise. 0.72. What is the ratio of the Aid flow from UN agencies (US$) in Middle East & North Africa (all income levels) in 2008 to that in 2013?
Your answer should be very brief. 0.88. What is the ratio of the Aid flow from UN agencies (US$) of Middle income in 2008 to that in 2013?
Ensure brevity in your answer.  0.88. What is the ratio of the Aid flow from UN agencies (US$) in Upper middle income in 2008 to that in 2013?
Provide a short and direct response. 0.86. What is the ratio of the Aid flow from UN agencies (US$) of Lebanon in 2008 to that in 2013?
Your answer should be very brief. 0.74. What is the ratio of the Aid flow from UN agencies (US$) in Middle East & North Africa (all income levels) in 2009 to that in 2010?
Keep it short and to the point. 0.87. What is the ratio of the Aid flow from UN agencies (US$) in Middle income in 2009 to that in 2010?
Your answer should be compact. 0.87. What is the ratio of the Aid flow from UN agencies (US$) of Upper middle income in 2009 to that in 2010?
Offer a very short reply. 0.91. What is the ratio of the Aid flow from UN agencies (US$) of Lebanon in 2009 to that in 2010?
Offer a very short reply. 0.94. What is the ratio of the Aid flow from UN agencies (US$) in Middle East & North Africa (all income levels) in 2009 to that in 2011?
Ensure brevity in your answer.  0.78. What is the ratio of the Aid flow from UN agencies (US$) in Upper middle income in 2009 to that in 2011?
Your answer should be compact. 0.88. What is the ratio of the Aid flow from UN agencies (US$) in Lebanon in 2009 to that in 2011?
Your answer should be compact. 0.87. What is the ratio of the Aid flow from UN agencies (US$) of Middle East & North Africa (all income levels) in 2009 to that in 2012?
Your answer should be compact. 0.71. What is the ratio of the Aid flow from UN agencies (US$) in Middle income in 2009 to that in 2012?
Ensure brevity in your answer.  0.71. What is the ratio of the Aid flow from UN agencies (US$) in Upper middle income in 2009 to that in 2012?
Offer a very short reply. 0.76. What is the ratio of the Aid flow from UN agencies (US$) of Lebanon in 2009 to that in 2012?
Your answer should be very brief. 0.79. What is the ratio of the Aid flow from UN agencies (US$) of Middle East & North Africa (all income levels) in 2009 to that in 2013?
Provide a short and direct response. 0.88. What is the ratio of the Aid flow from UN agencies (US$) in Middle income in 2009 to that in 2013?
Provide a succinct answer. 0.88. What is the ratio of the Aid flow from UN agencies (US$) of Upper middle income in 2009 to that in 2013?
Provide a succinct answer. 0.9. What is the ratio of the Aid flow from UN agencies (US$) of Lebanon in 2009 to that in 2013?
Provide a short and direct response. 0.82. What is the ratio of the Aid flow from UN agencies (US$) of Middle East & North Africa (all income levels) in 2010 to that in 2011?
Provide a succinct answer. 0.9. What is the ratio of the Aid flow from UN agencies (US$) of Middle income in 2010 to that in 2011?
Offer a terse response. 0.9. What is the ratio of the Aid flow from UN agencies (US$) of Upper middle income in 2010 to that in 2011?
Provide a short and direct response. 0.97. What is the ratio of the Aid flow from UN agencies (US$) in Lebanon in 2010 to that in 2011?
Give a very brief answer. 0.93. What is the ratio of the Aid flow from UN agencies (US$) of Middle East & North Africa (all income levels) in 2010 to that in 2012?
Your answer should be very brief. 0.82. What is the ratio of the Aid flow from UN agencies (US$) in Middle income in 2010 to that in 2012?
Provide a succinct answer. 0.82. What is the ratio of the Aid flow from UN agencies (US$) in Upper middle income in 2010 to that in 2012?
Offer a terse response. 0.83. What is the ratio of the Aid flow from UN agencies (US$) of Lebanon in 2010 to that in 2012?
Make the answer very short. 0.84. What is the ratio of the Aid flow from UN agencies (US$) of Middle East & North Africa (all income levels) in 2010 to that in 2013?
Give a very brief answer. 1.01. What is the ratio of the Aid flow from UN agencies (US$) of Middle income in 2010 to that in 2013?
Offer a very short reply. 1.01. What is the ratio of the Aid flow from UN agencies (US$) in Upper middle income in 2010 to that in 2013?
Your answer should be compact. 0.99. What is the ratio of the Aid flow from UN agencies (US$) of Lebanon in 2010 to that in 2013?
Offer a terse response. 0.86. What is the ratio of the Aid flow from UN agencies (US$) in Middle East & North Africa (all income levels) in 2011 to that in 2012?
Offer a very short reply. 0.91. What is the ratio of the Aid flow from UN agencies (US$) in Middle income in 2011 to that in 2012?
Your answer should be very brief. 0.91. What is the ratio of the Aid flow from UN agencies (US$) of Upper middle income in 2011 to that in 2012?
Your answer should be very brief. 0.86. What is the ratio of the Aid flow from UN agencies (US$) in Lebanon in 2011 to that in 2012?
Ensure brevity in your answer.  0.9. What is the ratio of the Aid flow from UN agencies (US$) in Middle East & North Africa (all income levels) in 2011 to that in 2013?
Provide a short and direct response. 1.13. What is the ratio of the Aid flow from UN agencies (US$) of Middle income in 2011 to that in 2013?
Make the answer very short. 1.13. What is the ratio of the Aid flow from UN agencies (US$) of Upper middle income in 2011 to that in 2013?
Your answer should be compact. 1.03. What is the ratio of the Aid flow from UN agencies (US$) of Lebanon in 2011 to that in 2013?
Offer a very short reply. 0.93. What is the ratio of the Aid flow from UN agencies (US$) of Middle East & North Africa (all income levels) in 2012 to that in 2013?
Offer a terse response. 1.24. What is the ratio of the Aid flow from UN agencies (US$) in Middle income in 2012 to that in 2013?
Provide a short and direct response. 1.24. What is the ratio of the Aid flow from UN agencies (US$) in Upper middle income in 2012 to that in 2013?
Keep it short and to the point. 1.19. What is the ratio of the Aid flow from UN agencies (US$) of Lebanon in 2012 to that in 2013?
Your answer should be compact. 1.03. What is the difference between the highest and the second highest Aid flow from UN agencies (US$) in Middle East & North Africa (all income levels)?
Offer a very short reply. 5.94e+07. What is the difference between the highest and the second highest Aid flow from UN agencies (US$) in Middle income?
Provide a short and direct response. 5.94e+07. What is the difference between the highest and the second highest Aid flow from UN agencies (US$) in Upper middle income?
Make the answer very short. 3.40e+07. What is the difference between the highest and the second highest Aid flow from UN agencies (US$) of Lebanon?
Keep it short and to the point. 2.58e+06. What is the difference between the highest and the lowest Aid flow from UN agencies (US$) in Middle East & North Africa (all income levels)?
Make the answer very short. 2.79e+08. What is the difference between the highest and the lowest Aid flow from UN agencies (US$) of Middle income?
Give a very brief answer. 2.79e+08. What is the difference between the highest and the lowest Aid flow from UN agencies (US$) of Upper middle income?
Your answer should be very brief. 9.40e+07. What is the difference between the highest and the lowest Aid flow from UN agencies (US$) of Lebanon?
Provide a succinct answer. 3.28e+07. 